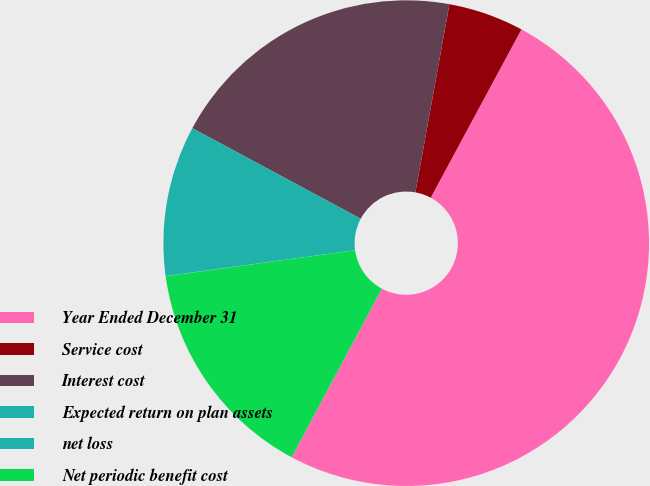Convert chart to OTSL. <chart><loc_0><loc_0><loc_500><loc_500><pie_chart><fcel>Year Ended December 31<fcel>Service cost<fcel>Interest cost<fcel>Expected return on plan assets<fcel>net loss<fcel>Net periodic benefit cost<nl><fcel>49.95%<fcel>5.02%<fcel>20.0%<fcel>10.01%<fcel>0.02%<fcel>15.0%<nl></chart> 